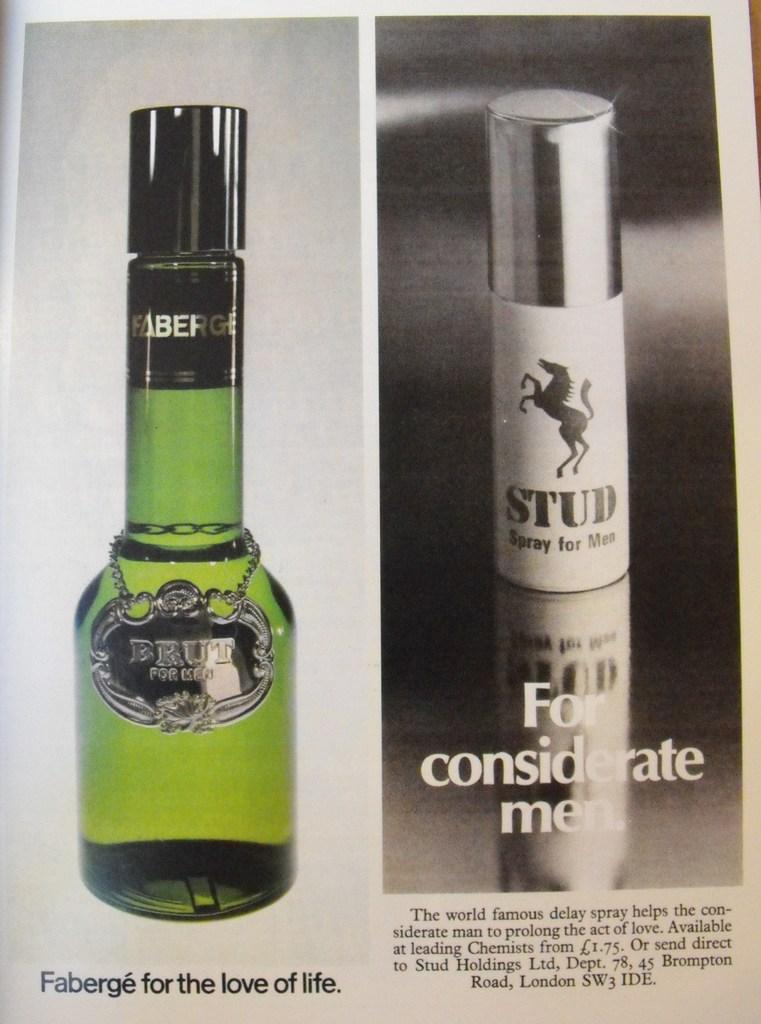<image>
Provide a brief description of the given image. Stud spray for men and Faberge for the love of life in a magazine 